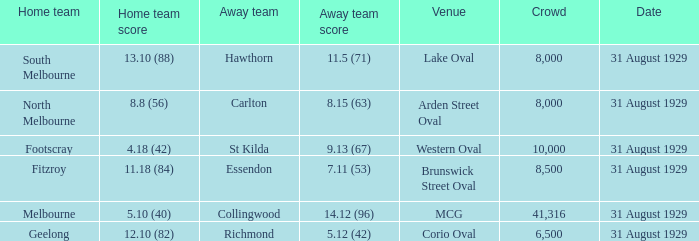What is the largest crowd when the away team is Hawthorn? 8000.0. 